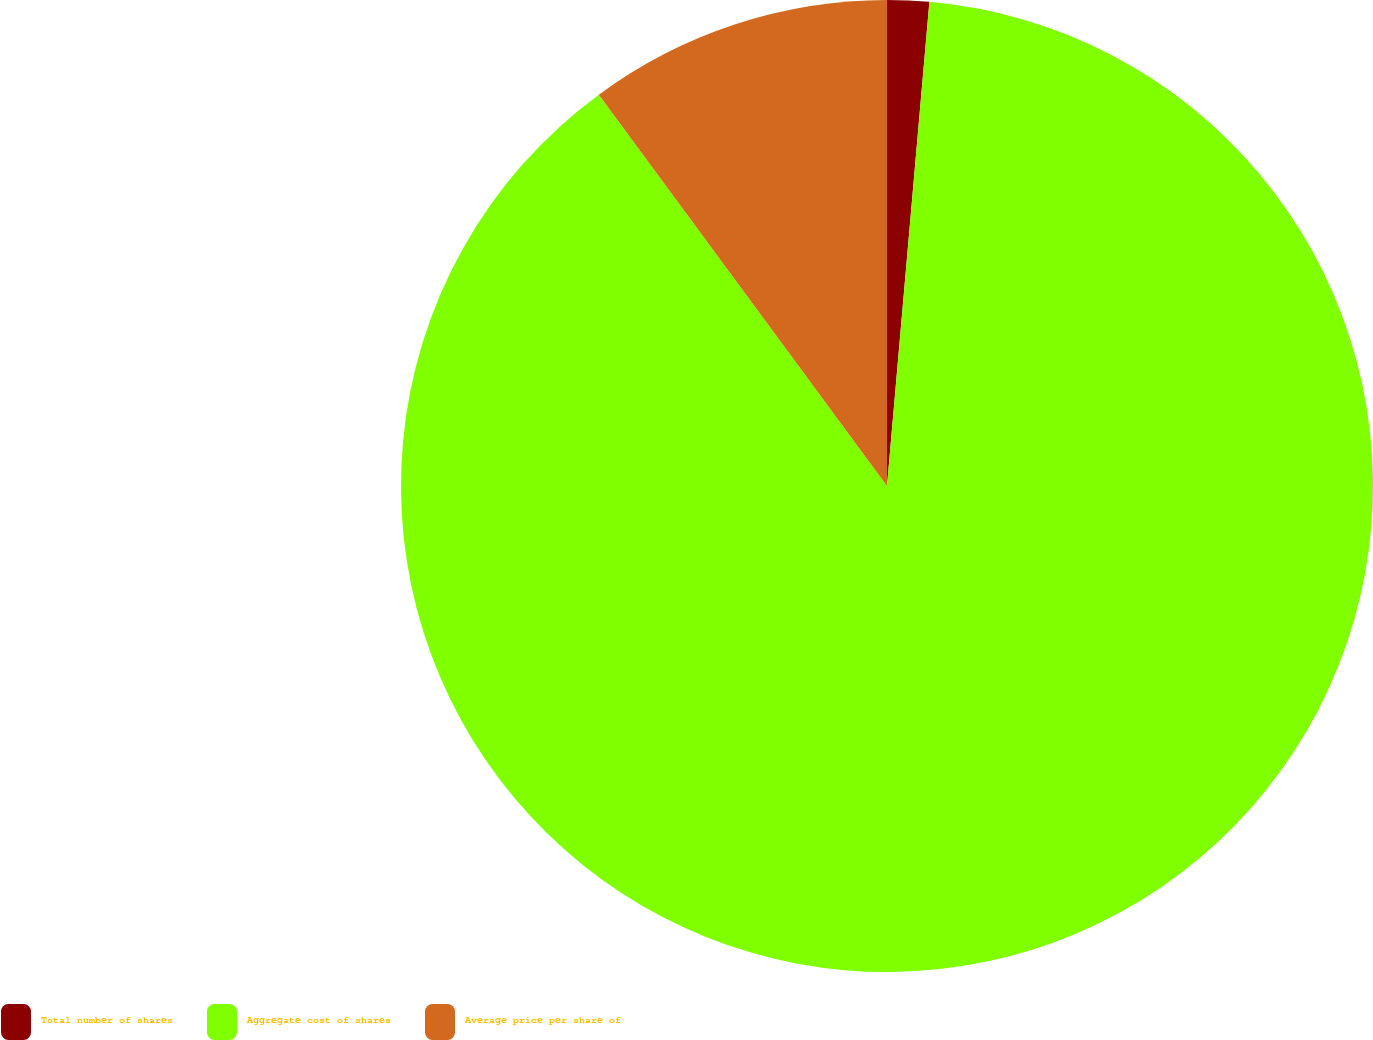<chart> <loc_0><loc_0><loc_500><loc_500><pie_chart><fcel>Total number of shares<fcel>Aggregate cost of shares<fcel>Average price per share of<nl><fcel>1.39%<fcel>88.5%<fcel>10.1%<nl></chart> 